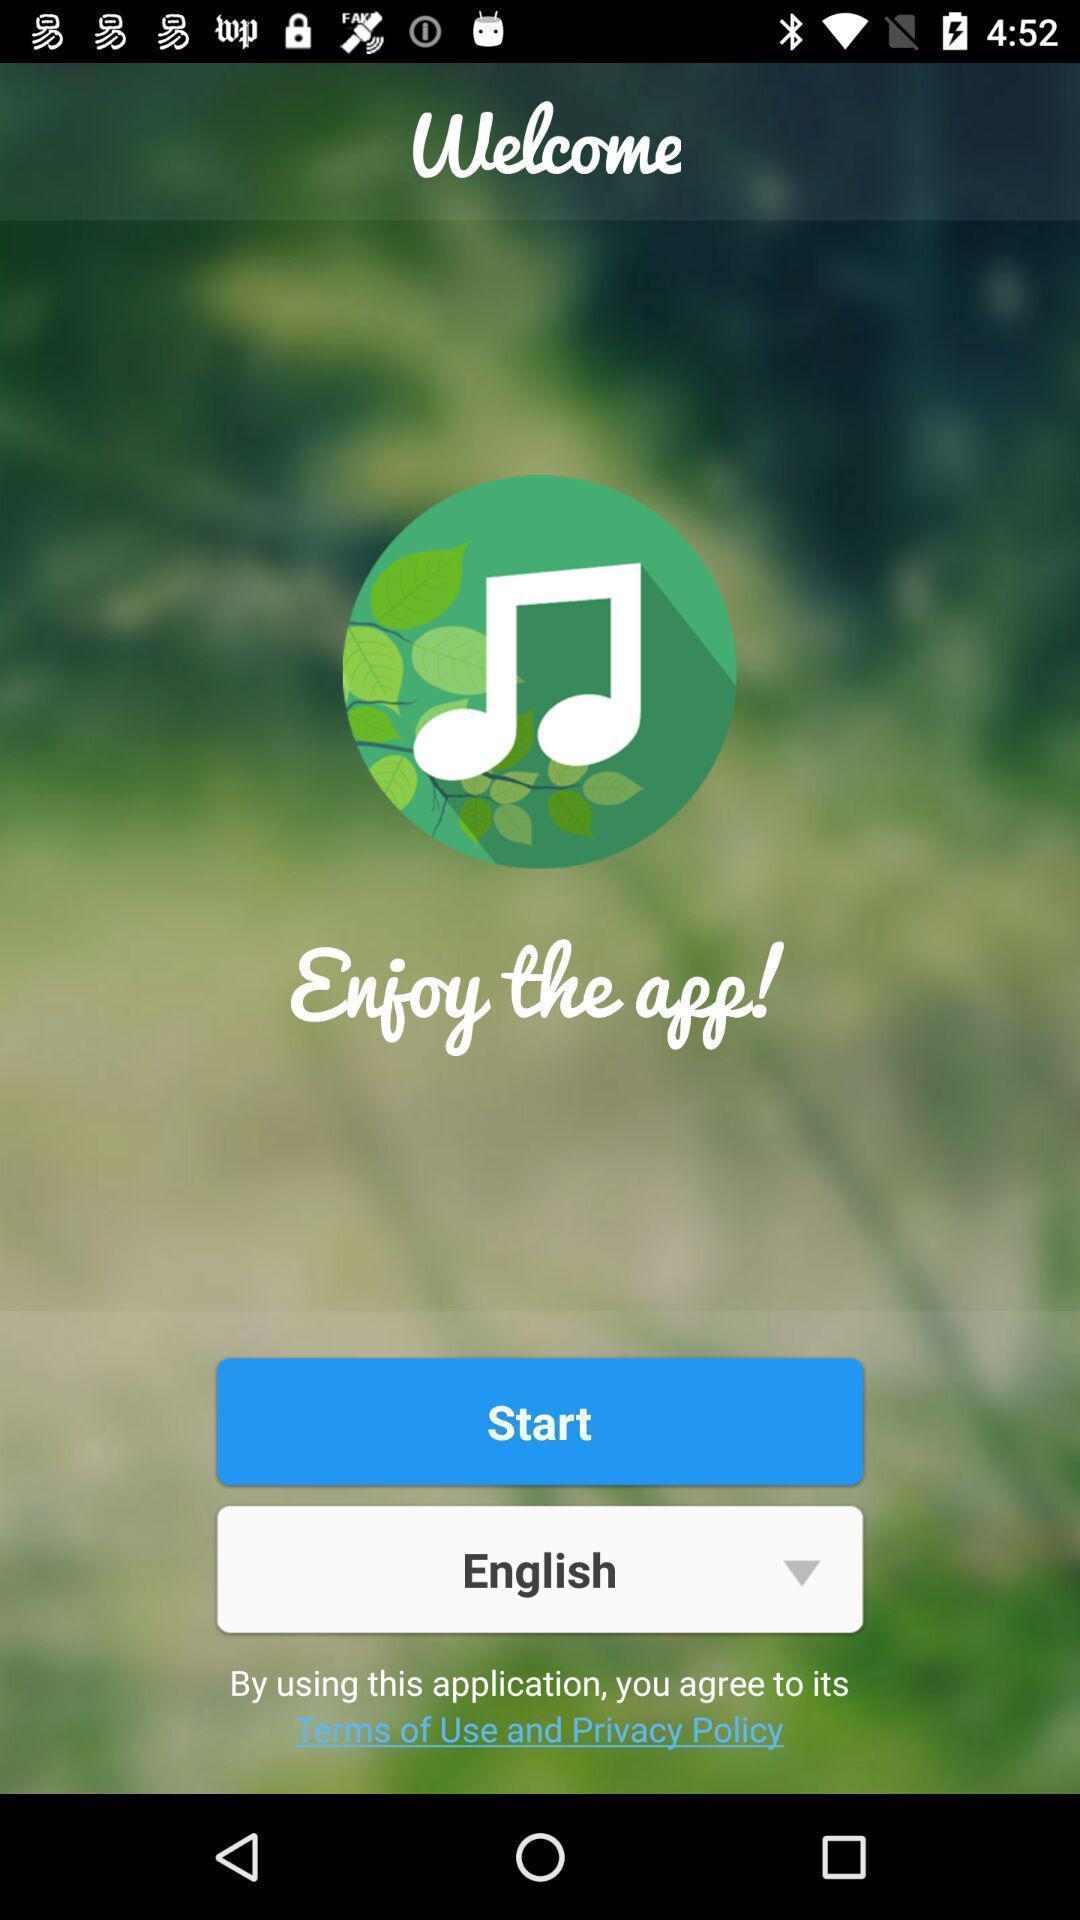Tell me what you see in this picture. Welcome page of the music app. 